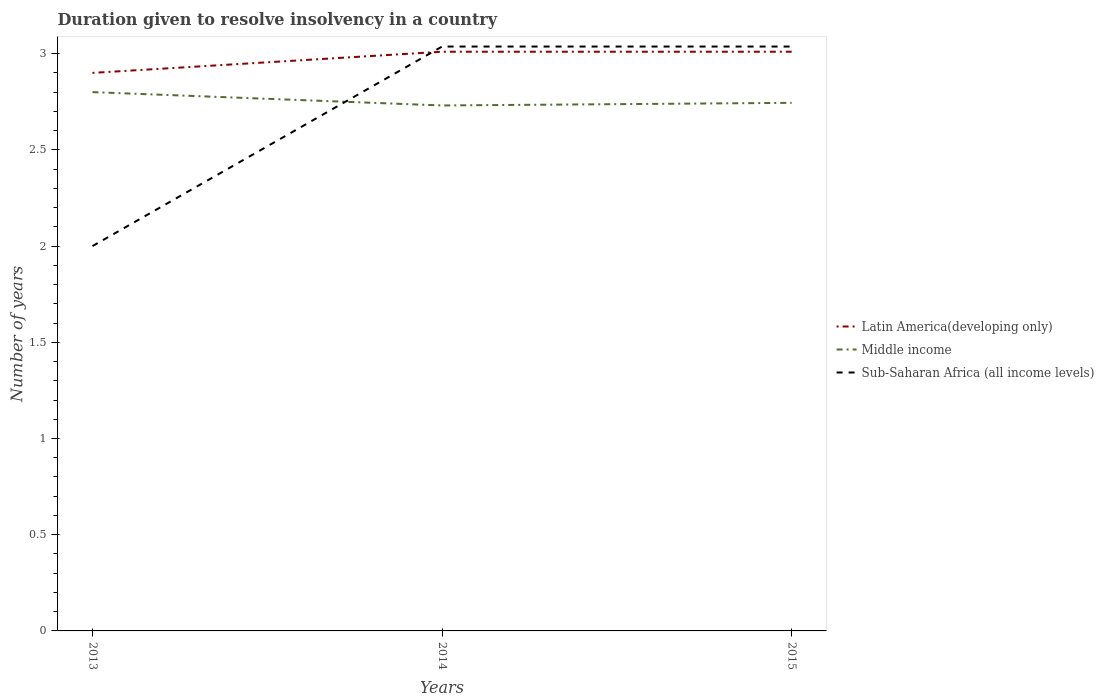Does the line corresponding to Latin America(developing only) intersect with the line corresponding to Middle income?
Make the answer very short. No. Is the number of lines equal to the number of legend labels?
Your response must be concise. Yes. Across all years, what is the maximum duration given to resolve insolvency in in Middle income?
Provide a succinct answer. 2.73. In which year was the duration given to resolve insolvency in in Latin America(developing only) maximum?
Provide a short and direct response. 2013. What is the total duration given to resolve insolvency in in Middle income in the graph?
Give a very brief answer. 0.07. What is the difference between the highest and the second highest duration given to resolve insolvency in in Latin America(developing only)?
Your response must be concise. 0.11. Is the duration given to resolve insolvency in in Sub-Saharan Africa (all income levels) strictly greater than the duration given to resolve insolvency in in Middle income over the years?
Give a very brief answer. No. What is the difference between two consecutive major ticks on the Y-axis?
Your response must be concise. 0.5. Are the values on the major ticks of Y-axis written in scientific E-notation?
Ensure brevity in your answer.  No. Does the graph contain any zero values?
Your response must be concise. No. How are the legend labels stacked?
Provide a succinct answer. Vertical. What is the title of the graph?
Keep it short and to the point. Duration given to resolve insolvency in a country. What is the label or title of the X-axis?
Make the answer very short. Years. What is the label or title of the Y-axis?
Ensure brevity in your answer.  Number of years. What is the Number of years of Latin America(developing only) in 2014?
Provide a short and direct response. 3.01. What is the Number of years in Middle income in 2014?
Provide a succinct answer. 2.73. What is the Number of years of Sub-Saharan Africa (all income levels) in 2014?
Provide a short and direct response. 3.04. What is the Number of years of Latin America(developing only) in 2015?
Provide a short and direct response. 3.01. What is the Number of years of Middle income in 2015?
Your response must be concise. 2.74. What is the Number of years in Sub-Saharan Africa (all income levels) in 2015?
Offer a very short reply. 3.04. Across all years, what is the maximum Number of years in Latin America(developing only)?
Provide a succinct answer. 3.01. Across all years, what is the maximum Number of years in Middle income?
Make the answer very short. 2.8. Across all years, what is the maximum Number of years of Sub-Saharan Africa (all income levels)?
Your answer should be very brief. 3.04. Across all years, what is the minimum Number of years of Latin America(developing only)?
Make the answer very short. 2.9. Across all years, what is the minimum Number of years in Middle income?
Your answer should be compact. 2.73. What is the total Number of years of Latin America(developing only) in the graph?
Make the answer very short. 8.92. What is the total Number of years in Middle income in the graph?
Your answer should be very brief. 8.28. What is the total Number of years in Sub-Saharan Africa (all income levels) in the graph?
Offer a terse response. 8.07. What is the difference between the Number of years in Latin America(developing only) in 2013 and that in 2014?
Offer a very short reply. -0.11. What is the difference between the Number of years of Middle income in 2013 and that in 2014?
Keep it short and to the point. 0.07. What is the difference between the Number of years of Sub-Saharan Africa (all income levels) in 2013 and that in 2014?
Offer a terse response. -1.04. What is the difference between the Number of years of Latin America(developing only) in 2013 and that in 2015?
Your answer should be compact. -0.11. What is the difference between the Number of years in Middle income in 2013 and that in 2015?
Offer a very short reply. 0.06. What is the difference between the Number of years of Sub-Saharan Africa (all income levels) in 2013 and that in 2015?
Provide a succinct answer. -1.04. What is the difference between the Number of years of Latin America(developing only) in 2014 and that in 2015?
Ensure brevity in your answer.  0. What is the difference between the Number of years in Middle income in 2014 and that in 2015?
Your answer should be very brief. -0.01. What is the difference between the Number of years in Latin America(developing only) in 2013 and the Number of years in Middle income in 2014?
Your answer should be very brief. 0.17. What is the difference between the Number of years of Latin America(developing only) in 2013 and the Number of years of Sub-Saharan Africa (all income levels) in 2014?
Your answer should be very brief. -0.14. What is the difference between the Number of years of Middle income in 2013 and the Number of years of Sub-Saharan Africa (all income levels) in 2014?
Your response must be concise. -0.24. What is the difference between the Number of years of Latin America(developing only) in 2013 and the Number of years of Middle income in 2015?
Your response must be concise. 0.16. What is the difference between the Number of years in Latin America(developing only) in 2013 and the Number of years in Sub-Saharan Africa (all income levels) in 2015?
Keep it short and to the point. -0.14. What is the difference between the Number of years of Middle income in 2013 and the Number of years of Sub-Saharan Africa (all income levels) in 2015?
Provide a short and direct response. -0.24. What is the difference between the Number of years in Latin America(developing only) in 2014 and the Number of years in Middle income in 2015?
Your answer should be very brief. 0.27. What is the difference between the Number of years in Latin America(developing only) in 2014 and the Number of years in Sub-Saharan Africa (all income levels) in 2015?
Your response must be concise. -0.03. What is the difference between the Number of years of Middle income in 2014 and the Number of years of Sub-Saharan Africa (all income levels) in 2015?
Your answer should be very brief. -0.31. What is the average Number of years in Latin America(developing only) per year?
Offer a very short reply. 2.97. What is the average Number of years in Middle income per year?
Your response must be concise. 2.76. What is the average Number of years in Sub-Saharan Africa (all income levels) per year?
Your answer should be compact. 2.69. In the year 2013, what is the difference between the Number of years in Latin America(developing only) and Number of years in Sub-Saharan Africa (all income levels)?
Offer a terse response. 0.9. In the year 2014, what is the difference between the Number of years in Latin America(developing only) and Number of years in Middle income?
Your answer should be very brief. 0.28. In the year 2014, what is the difference between the Number of years of Latin America(developing only) and Number of years of Sub-Saharan Africa (all income levels)?
Keep it short and to the point. -0.03. In the year 2014, what is the difference between the Number of years of Middle income and Number of years of Sub-Saharan Africa (all income levels)?
Ensure brevity in your answer.  -0.31. In the year 2015, what is the difference between the Number of years in Latin America(developing only) and Number of years in Middle income?
Give a very brief answer. 0.27. In the year 2015, what is the difference between the Number of years in Latin America(developing only) and Number of years in Sub-Saharan Africa (all income levels)?
Offer a very short reply. -0.03. In the year 2015, what is the difference between the Number of years in Middle income and Number of years in Sub-Saharan Africa (all income levels)?
Your answer should be compact. -0.29. What is the ratio of the Number of years in Latin America(developing only) in 2013 to that in 2014?
Your answer should be compact. 0.96. What is the ratio of the Number of years in Middle income in 2013 to that in 2014?
Provide a succinct answer. 1.03. What is the ratio of the Number of years in Sub-Saharan Africa (all income levels) in 2013 to that in 2014?
Give a very brief answer. 0.66. What is the ratio of the Number of years in Latin America(developing only) in 2013 to that in 2015?
Your response must be concise. 0.96. What is the ratio of the Number of years in Middle income in 2013 to that in 2015?
Provide a short and direct response. 1.02. What is the ratio of the Number of years of Sub-Saharan Africa (all income levels) in 2013 to that in 2015?
Keep it short and to the point. 0.66. What is the ratio of the Number of years in Middle income in 2014 to that in 2015?
Provide a succinct answer. 0.99. What is the difference between the highest and the second highest Number of years of Latin America(developing only)?
Your answer should be very brief. 0. What is the difference between the highest and the second highest Number of years in Middle income?
Your answer should be very brief. 0.06. What is the difference between the highest and the lowest Number of years in Latin America(developing only)?
Ensure brevity in your answer.  0.11. What is the difference between the highest and the lowest Number of years in Middle income?
Offer a terse response. 0.07. What is the difference between the highest and the lowest Number of years in Sub-Saharan Africa (all income levels)?
Your response must be concise. 1.04. 